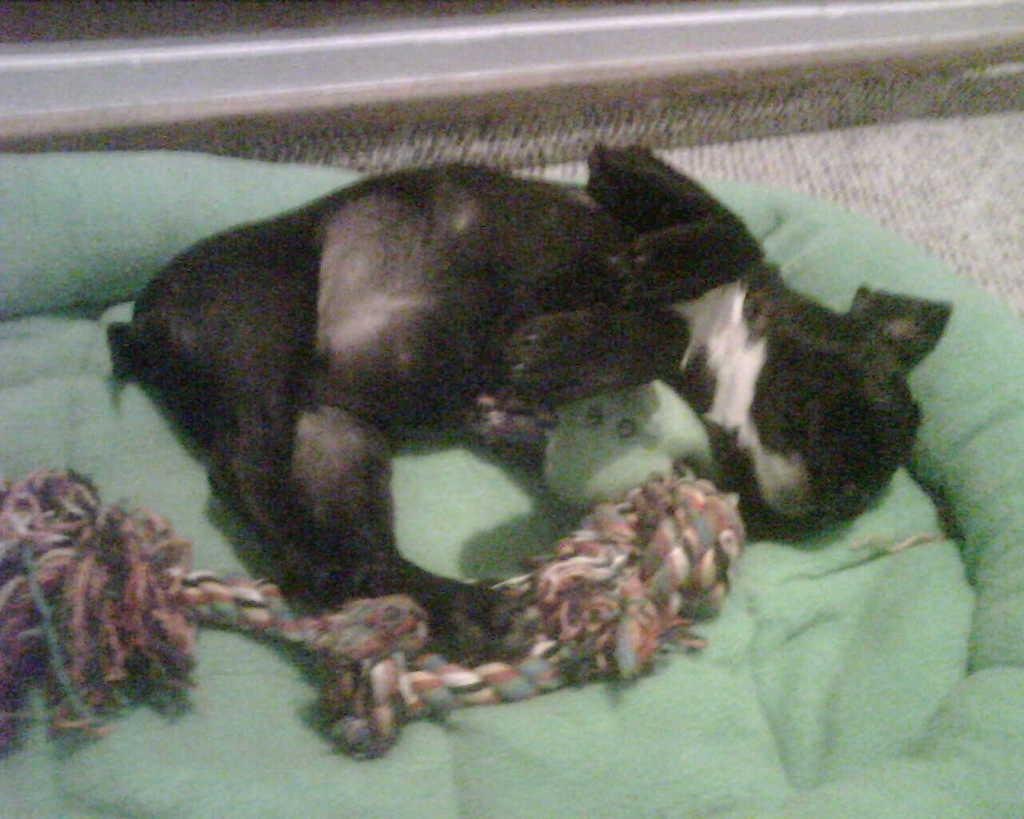What is the main subject of the image? There is an animal lying on a bed in the image. What color is the bed? The bed is green in color. What is the animal holding? The animal is holding something. What can be seen in the background of the image? There is a metal road visible in the background of the image. What type of paste is being used to write the caption on the image? There is no paste or caption present in the image; it is a photograph of an animal lying on a bed with a metal road in the background. 